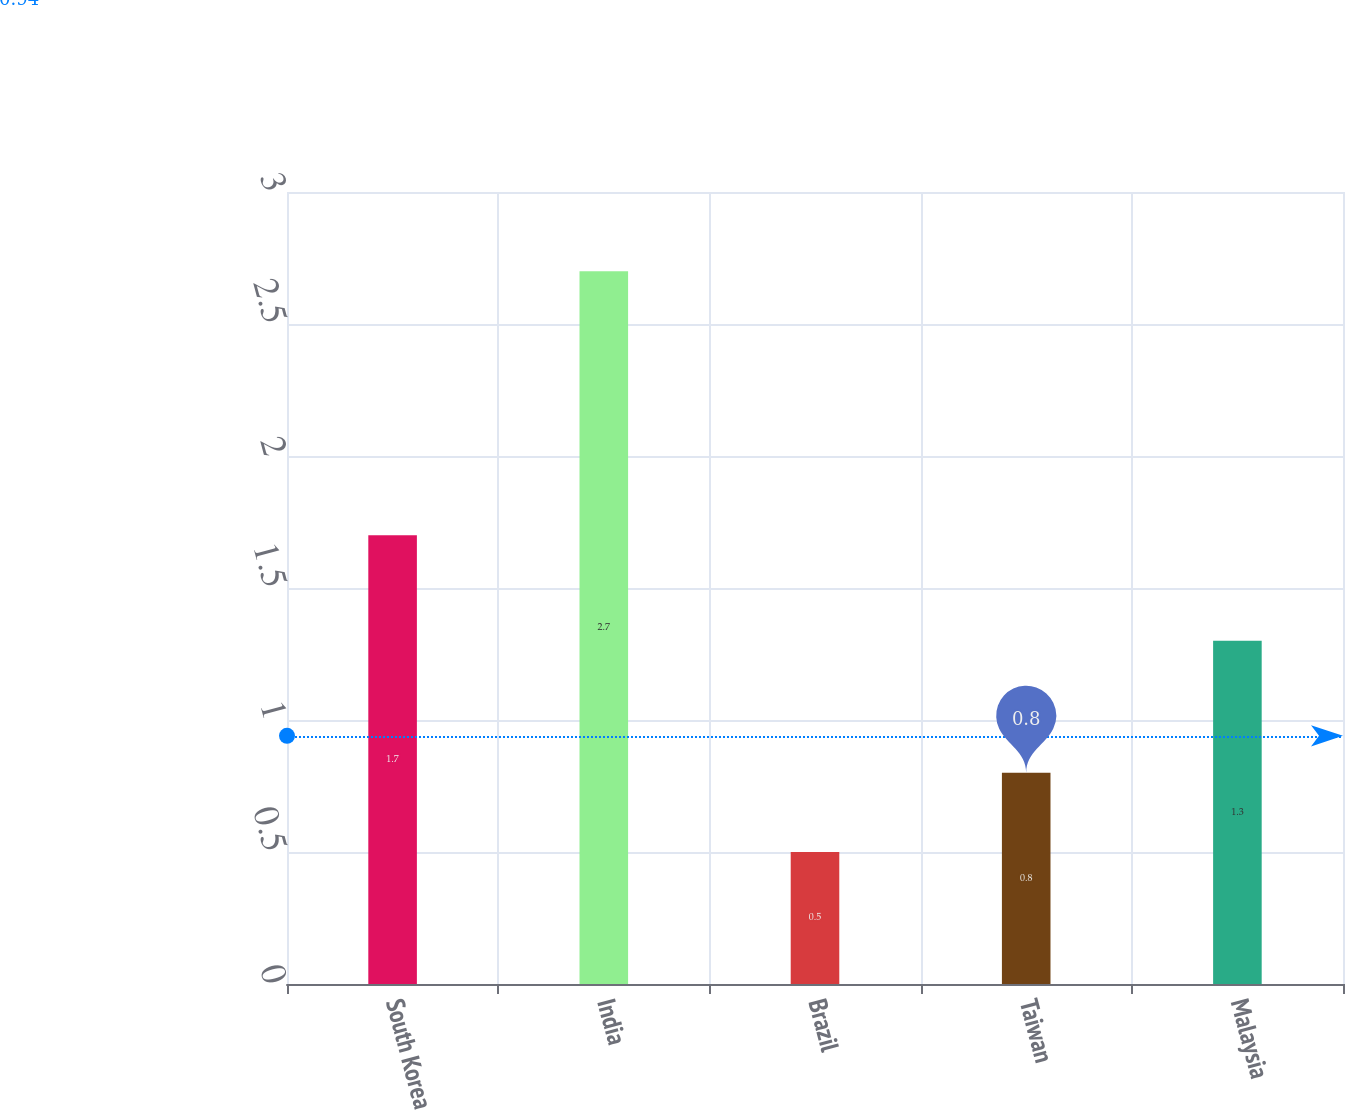<chart> <loc_0><loc_0><loc_500><loc_500><bar_chart><fcel>South Korea<fcel>India<fcel>Brazil<fcel>Taiwan<fcel>Malaysia<nl><fcel>1.7<fcel>2.7<fcel>0.5<fcel>0.8<fcel>1.3<nl></chart> 